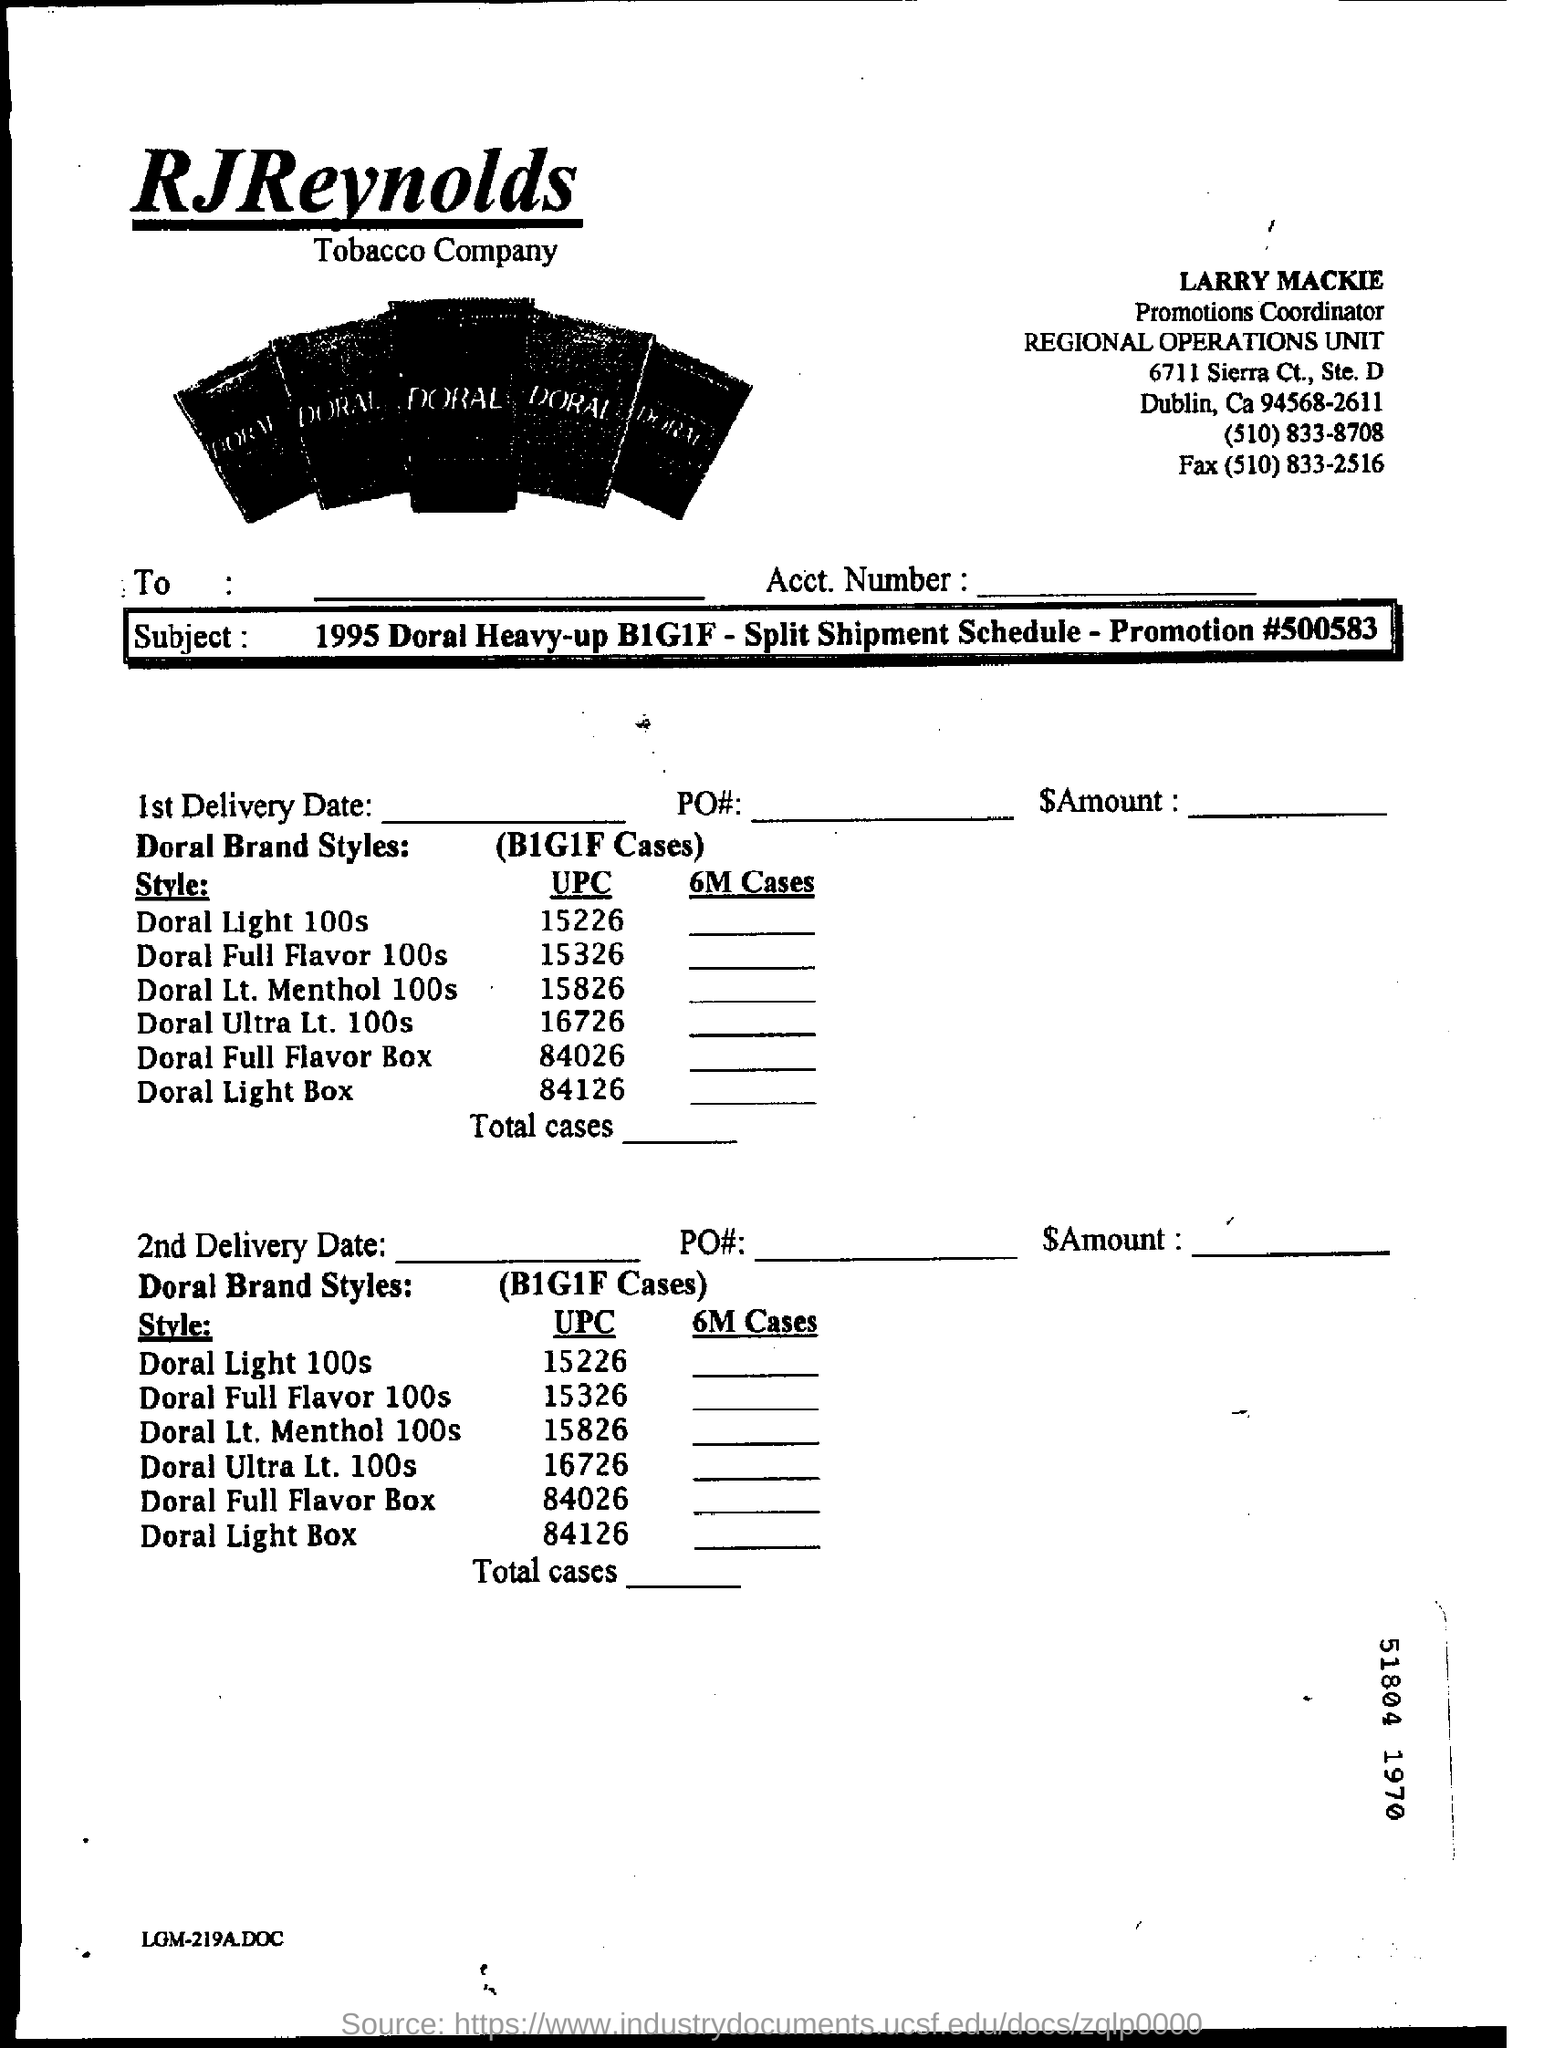Identify some key points in this picture. RJ Reynolds, the tobacco company, is mentioned in the form. Larry Mackie is the promotions coordinator. The product to be delivered is a Doral brand style in which one unit is delivered for every two units purchased, with one case containing one pallet of six units, for a total of one case with one for every two. The fax number mentioned is (510) 833-2516. The promotion number is 500583. 